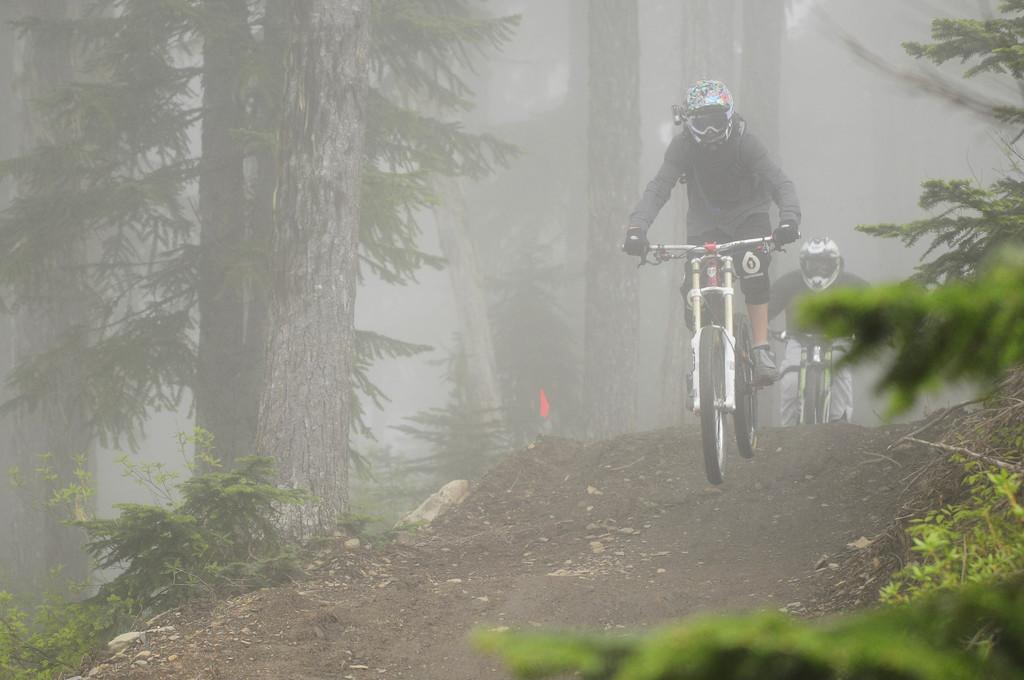What are the people in the image doing? The people in the image are riding bicycles. What type of vegetation can be seen in the image? There are trees and plants visible in the image. What time is displayed on the watch worn by the person riding the bicycle in the image? There is no watch visible in the image, so it is not possible to determine the time. 